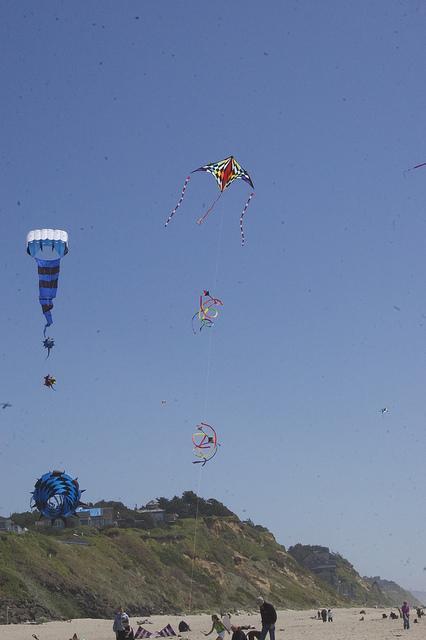What natural disaster are those houses likely safe from?
Choose the right answer and clarify with the format: 'Answer: answer
Rationale: rationale.'
Options: Win storm, dust storm, flooding, tornado. Answer: flooding.
Rationale: The house are very high up on a cliff. 